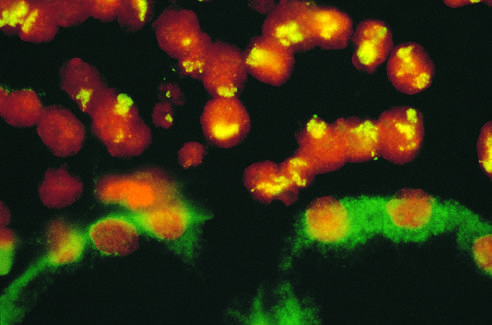s fish using a fluorescein-labeled cosmid probe for n-myc on a tissue section containing neuroblastoma attached to the kidney?
Answer the question using a single word or phrase. Yes 